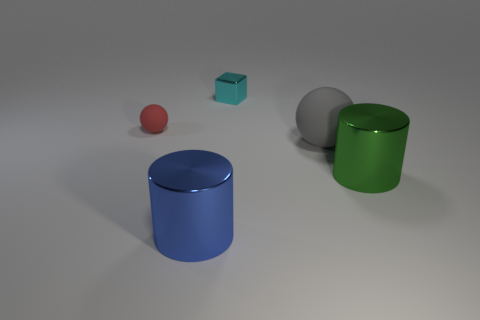Add 5 blue cylinders. How many objects exist? 10 Subtract all green cylinders. How many cylinders are left? 1 Subtract all yellow blocks. Subtract all green balls. How many blocks are left? 1 Subtract all cyan balls. How many gray cubes are left? 0 Subtract all purple things. Subtract all large green shiny cylinders. How many objects are left? 4 Add 2 large blue metal objects. How many large blue metal objects are left? 3 Add 2 blue shiny things. How many blue shiny things exist? 3 Subtract 0 gray cylinders. How many objects are left? 5 Subtract all cylinders. How many objects are left? 3 Subtract 2 cylinders. How many cylinders are left? 0 